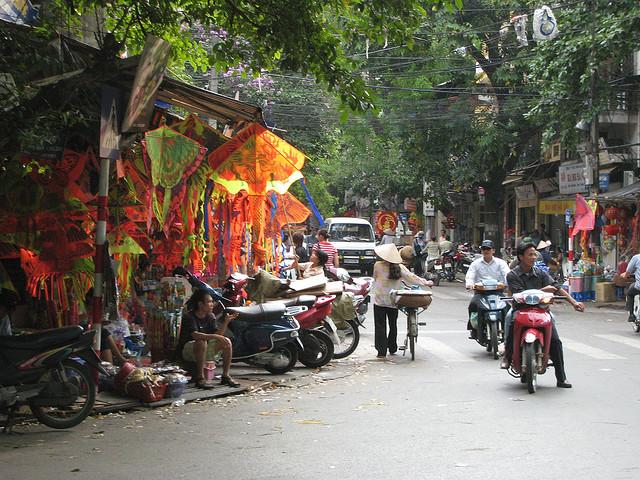Is this in the United States?
Quick response, please. No. What is on the sidewalk?
Concise answer only. Motorcycles. What number of motorcycles are driving down the street?
Answer briefly. 2. 